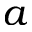<formula> <loc_0><loc_0><loc_500><loc_500>a</formula> 